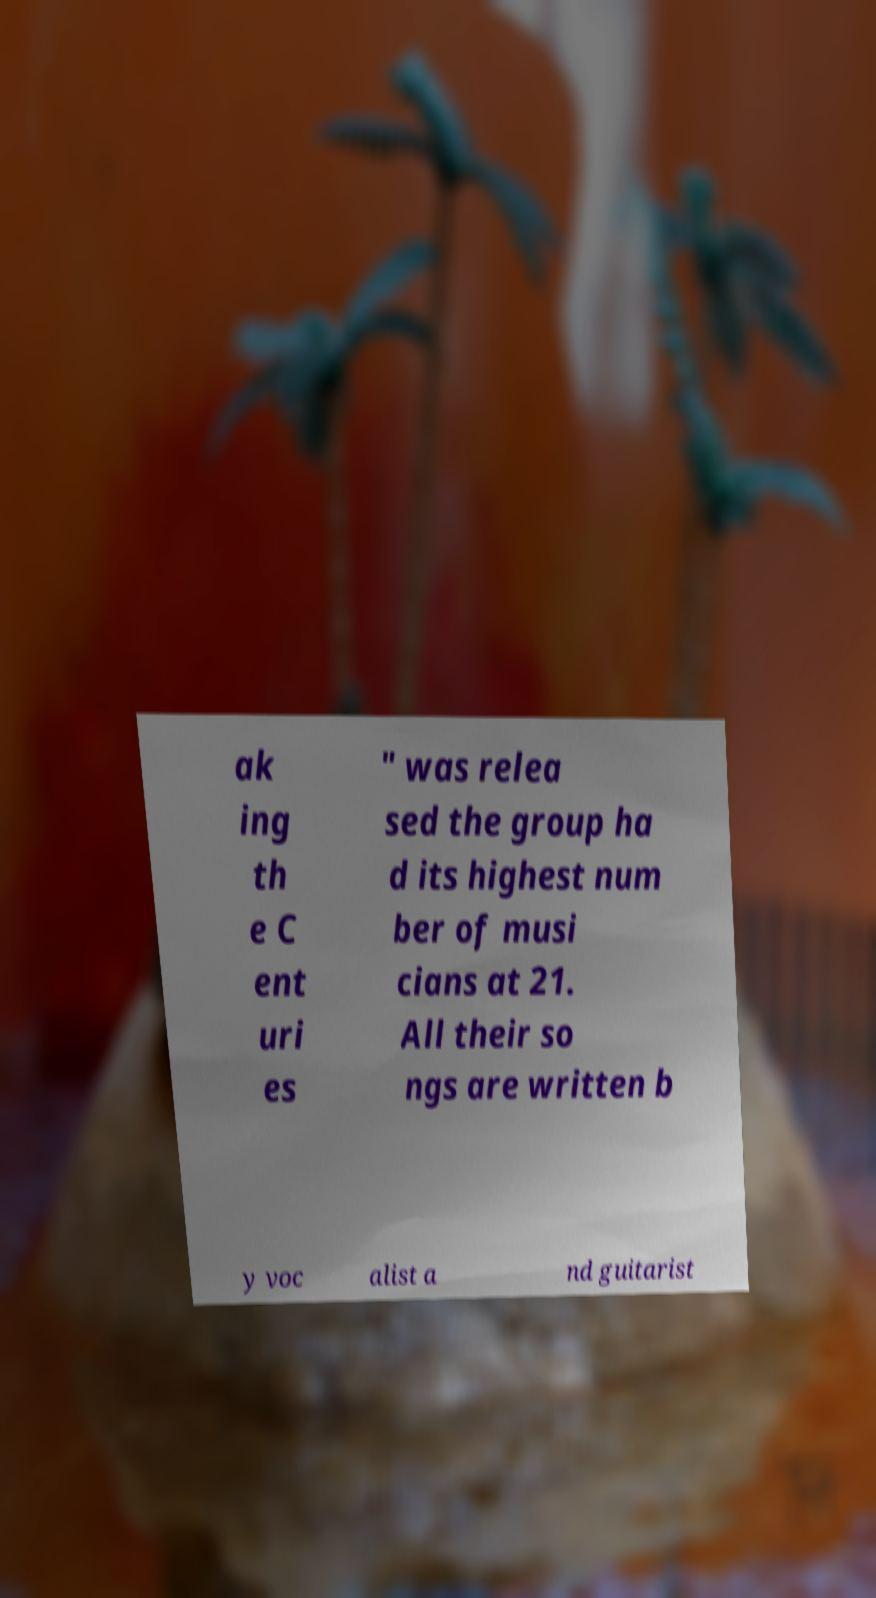There's text embedded in this image that I need extracted. Can you transcribe it verbatim? ak ing th e C ent uri es " was relea sed the group ha d its highest num ber of musi cians at 21. All their so ngs are written b y voc alist a nd guitarist 